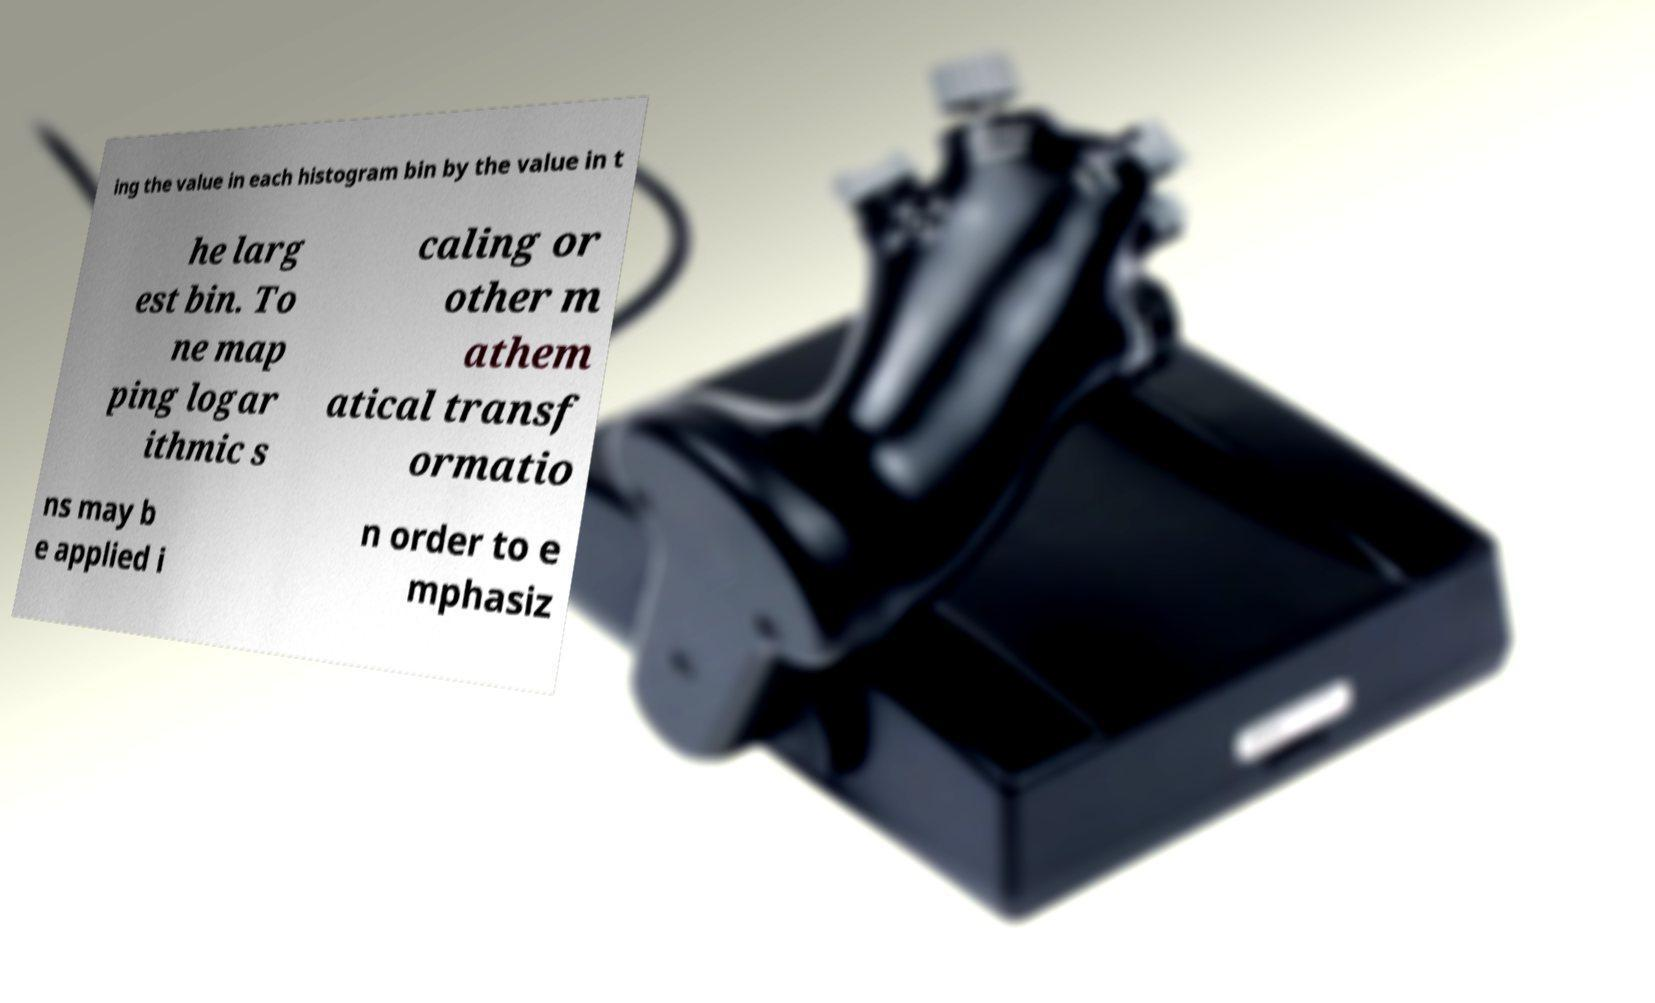Could you extract and type out the text from this image? ing the value in each histogram bin by the value in t he larg est bin. To ne map ping logar ithmic s caling or other m athem atical transf ormatio ns may b e applied i n order to e mphasiz 